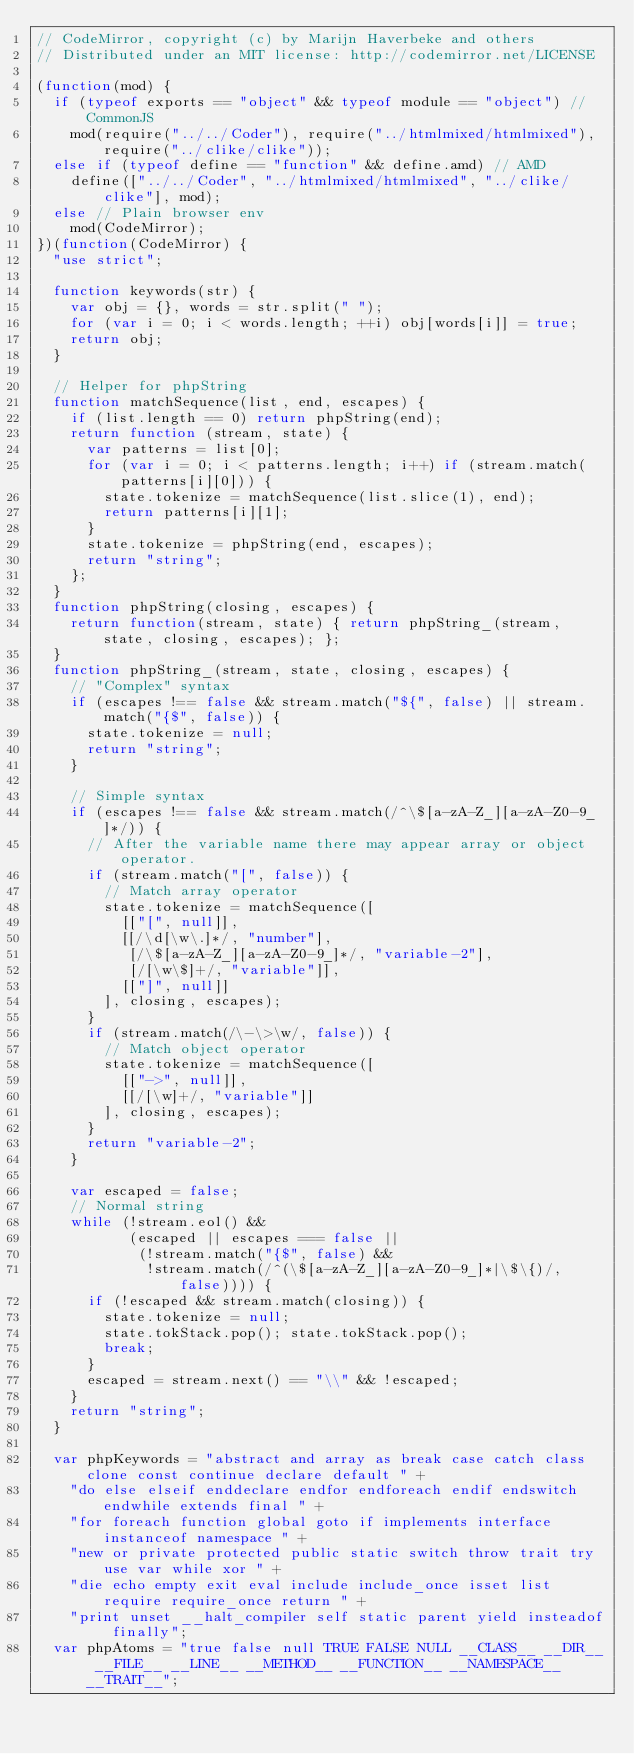<code> <loc_0><loc_0><loc_500><loc_500><_JavaScript_>// CodeMirror, copyright (c) by Marijn Haverbeke and others
// Distributed under an MIT license: http://codemirror.net/LICENSE

(function(mod) {
  if (typeof exports == "object" && typeof module == "object") // CommonJS
    mod(require("../../Coder"), require("../htmlmixed/htmlmixed"), require("../clike/clike"));
  else if (typeof define == "function" && define.amd) // AMD
    define(["../../Coder", "../htmlmixed/htmlmixed", "../clike/clike"], mod);
  else // Plain browser env
    mod(CodeMirror);
})(function(CodeMirror) {
  "use strict";

  function keywords(str) {
    var obj = {}, words = str.split(" ");
    for (var i = 0; i < words.length; ++i) obj[words[i]] = true;
    return obj;
  }

  // Helper for phpString
  function matchSequence(list, end, escapes) {
    if (list.length == 0) return phpString(end);
    return function (stream, state) {
      var patterns = list[0];
      for (var i = 0; i < patterns.length; i++) if (stream.match(patterns[i][0])) {
        state.tokenize = matchSequence(list.slice(1), end);
        return patterns[i][1];
      }
      state.tokenize = phpString(end, escapes);
      return "string";
    };
  }
  function phpString(closing, escapes) {
    return function(stream, state) { return phpString_(stream, state, closing, escapes); };
  }
  function phpString_(stream, state, closing, escapes) {
    // "Complex" syntax
    if (escapes !== false && stream.match("${", false) || stream.match("{$", false)) {
      state.tokenize = null;
      return "string";
    }

    // Simple syntax
    if (escapes !== false && stream.match(/^\$[a-zA-Z_][a-zA-Z0-9_]*/)) {
      // After the variable name there may appear array or object operator.
      if (stream.match("[", false)) {
        // Match array operator
        state.tokenize = matchSequence([
          [["[", null]],
          [[/\d[\w\.]*/, "number"],
           [/\$[a-zA-Z_][a-zA-Z0-9_]*/, "variable-2"],
           [/[\w\$]+/, "variable"]],
          [["]", null]]
        ], closing, escapes);
      }
      if (stream.match(/\-\>\w/, false)) {
        // Match object operator
        state.tokenize = matchSequence([
          [["->", null]],
          [[/[\w]+/, "variable"]]
        ], closing, escapes);
      }
      return "variable-2";
    }

    var escaped = false;
    // Normal string
    while (!stream.eol() &&
           (escaped || escapes === false ||
            (!stream.match("{$", false) &&
             !stream.match(/^(\$[a-zA-Z_][a-zA-Z0-9_]*|\$\{)/, false)))) {
      if (!escaped && stream.match(closing)) {
        state.tokenize = null;
        state.tokStack.pop(); state.tokStack.pop();
        break;
      }
      escaped = stream.next() == "\\" && !escaped;
    }
    return "string";
  }

  var phpKeywords = "abstract and array as break case catch class clone const continue declare default " +
    "do else elseif enddeclare endfor endforeach endif endswitch endwhile extends final " +
    "for foreach function global goto if implements interface instanceof namespace " +
    "new or private protected public static switch throw trait try use var while xor " +
    "die echo empty exit eval include include_once isset list require require_once return " +
    "print unset __halt_compiler self static parent yield insteadof finally";
  var phpAtoms = "true false null TRUE FALSE NULL __CLASS__ __DIR__ __FILE__ __LINE__ __METHOD__ __FUNCTION__ __NAMESPACE__ __TRAIT__";</code> 